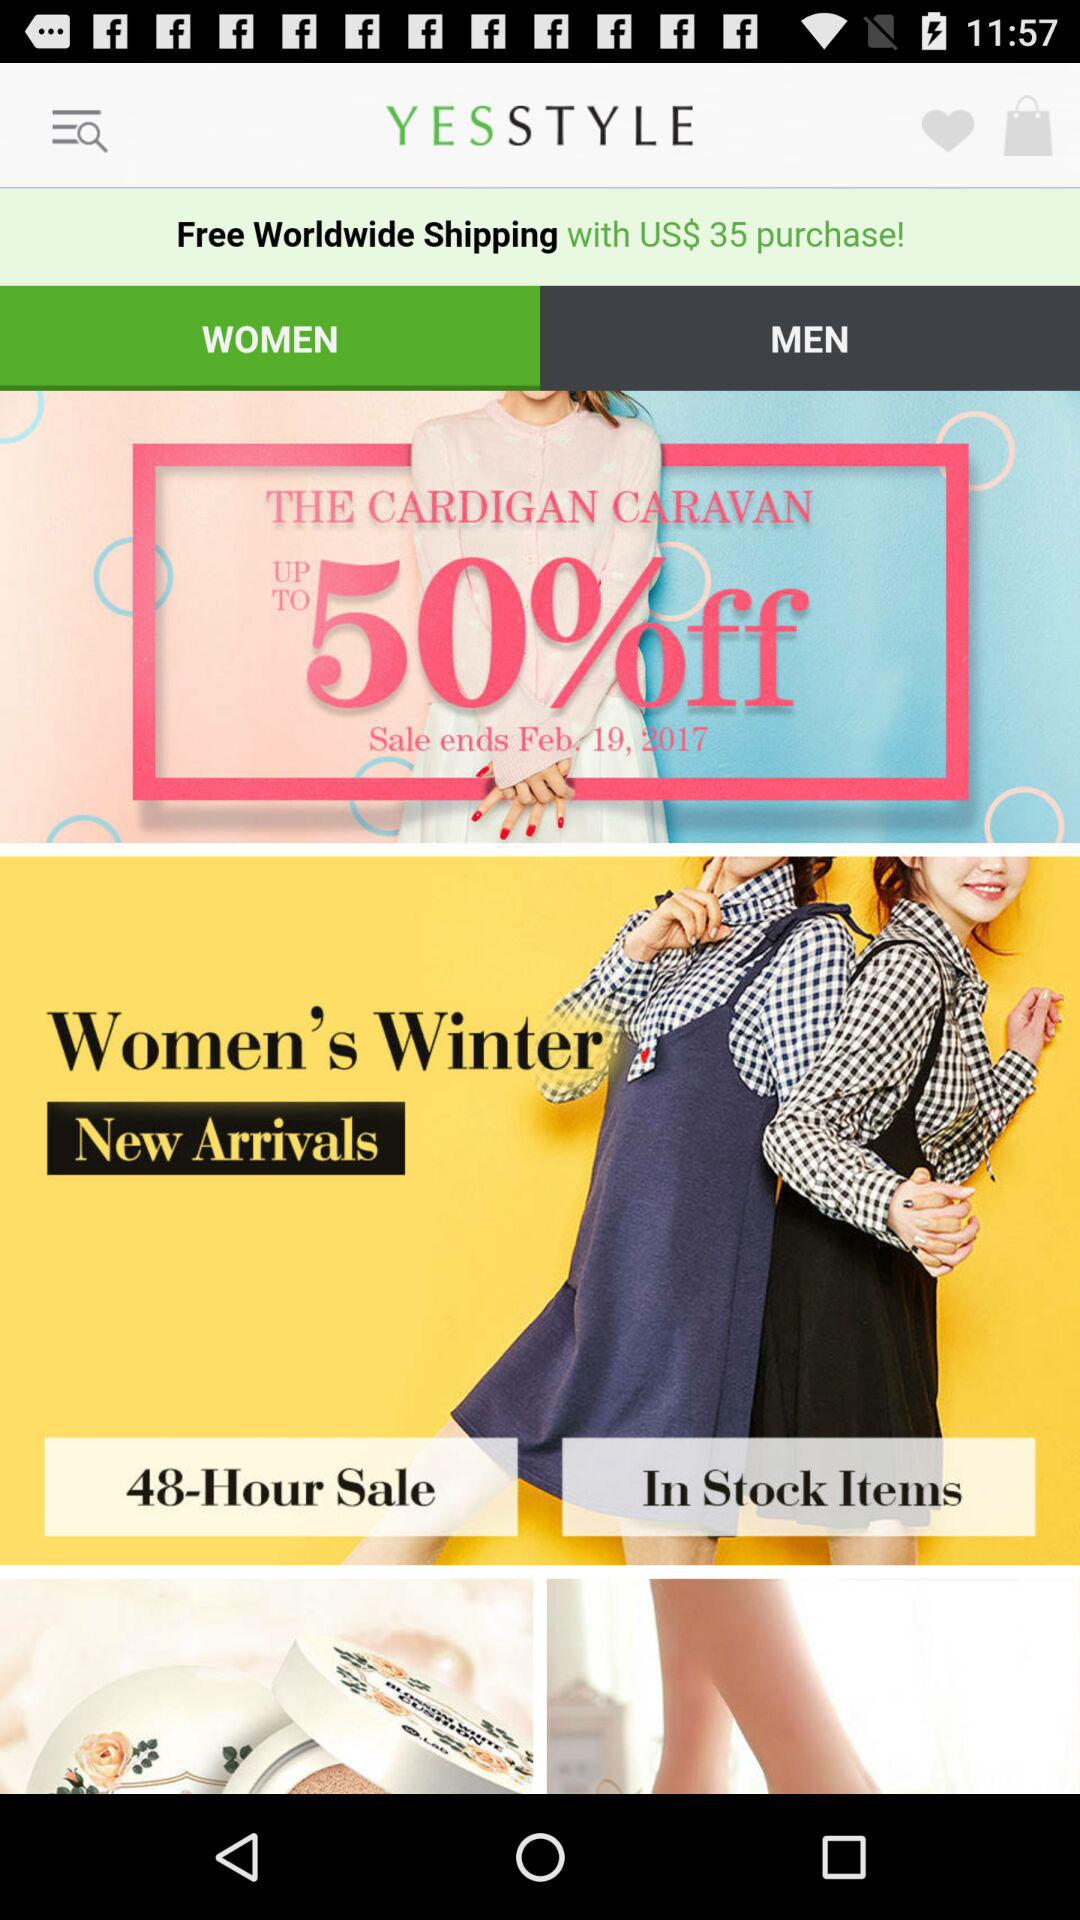What is the discount on "THE CARDIGAN CARAVAN"? The discount on "THE CARDIGAN CARAVAN" is up to 50%. 